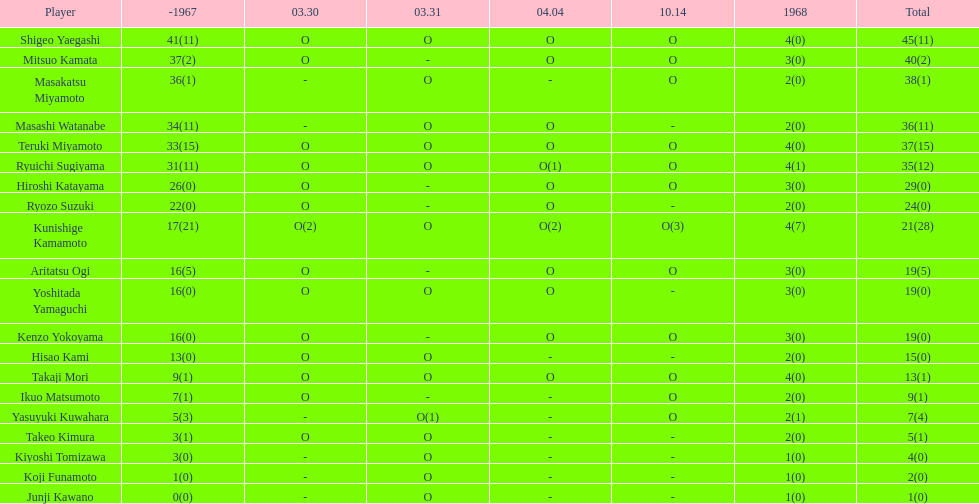Total appearances by masakatsu miyamoto? 38. 